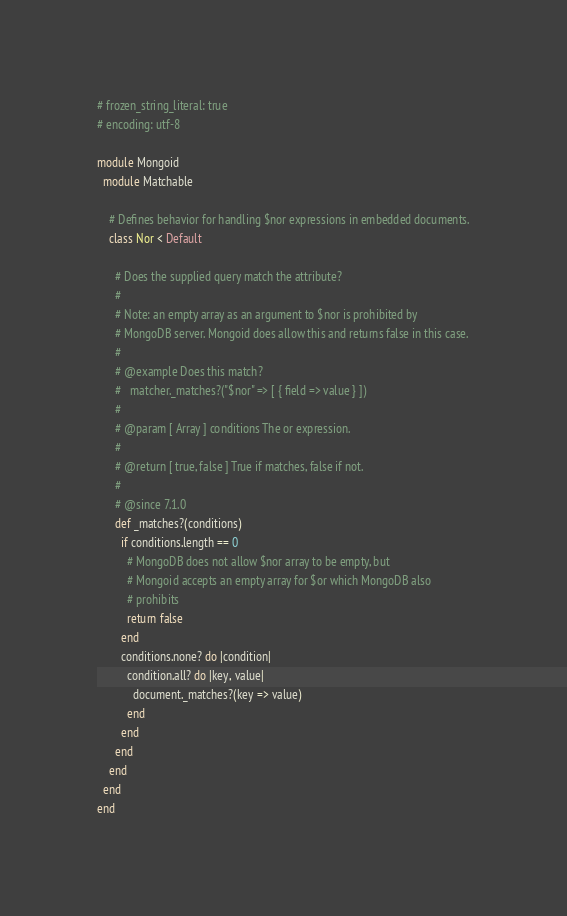Convert code to text. <code><loc_0><loc_0><loc_500><loc_500><_Ruby_># frozen_string_literal: true
# encoding: utf-8

module Mongoid
  module Matchable

    # Defines behavior for handling $nor expressions in embedded documents.
    class Nor < Default

      # Does the supplied query match the attribute?
      #
      # Note: an empty array as an argument to $nor is prohibited by
      # MongoDB server. Mongoid does allow this and returns false in this case.
      #
      # @example Does this match?
      #   matcher._matches?("$nor" => [ { field => value } ])
      #
      # @param [ Array ] conditions The or expression.
      #
      # @return [ true, false ] True if matches, false if not.
      #
      # @since 7.1.0
      def _matches?(conditions)
        if conditions.length == 0
          # MongoDB does not allow $nor array to be empty, but
          # Mongoid accepts an empty array for $or which MongoDB also
          # prohibits
          return false
        end
        conditions.none? do |condition|
          condition.all? do |key, value|
            document._matches?(key => value)
          end
        end
      end
    end
  end
end
</code> 